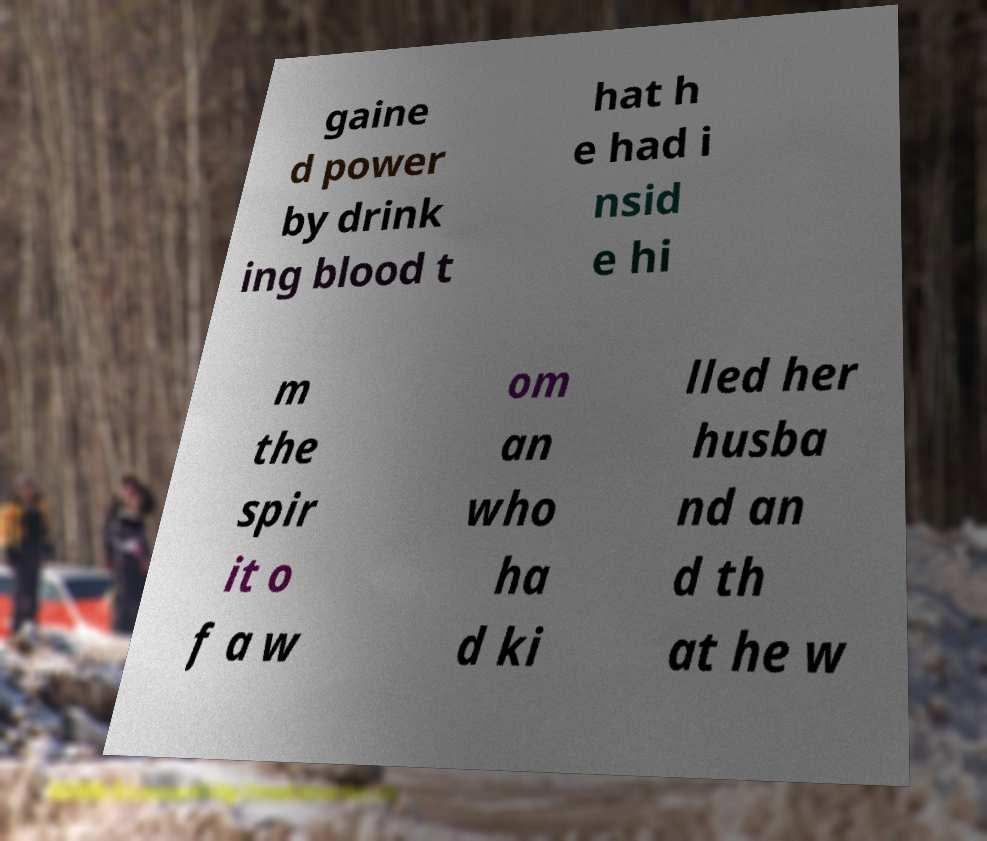Please read and relay the text visible in this image. What does it say? gaine d power by drink ing blood t hat h e had i nsid e hi m the spir it o f a w om an who ha d ki lled her husba nd an d th at he w 